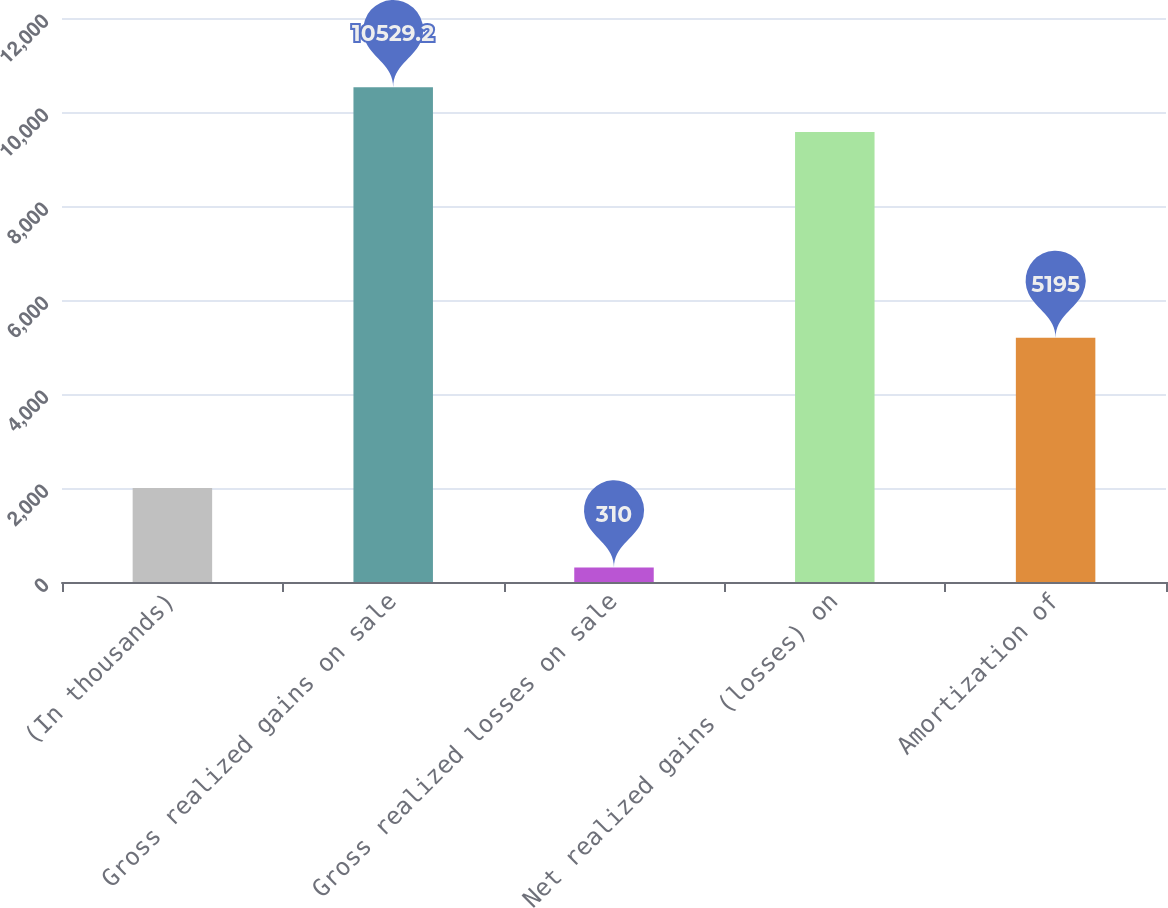Convert chart to OTSL. <chart><loc_0><loc_0><loc_500><loc_500><bar_chart><fcel>(In thousands)<fcel>Gross realized gains on sale<fcel>Gross realized losses on sale<fcel>Net realized gains (losses) on<fcel>Amortization of<nl><fcel>2002<fcel>10529.2<fcel>310<fcel>9572<fcel>5195<nl></chart> 